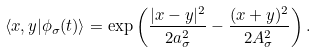Convert formula to latex. <formula><loc_0><loc_0><loc_500><loc_500>\langle { x } , { y } | \phi _ { \sigma } ( t ) \rangle = \exp \left ( \frac { | { x } - { y } | ^ { 2 } } { 2 a ^ { 2 } _ { \sigma } } - \frac { ( { x } + { y } ) ^ { 2 } } { 2 A ^ { 2 } _ { \sigma } } \right ) .</formula> 